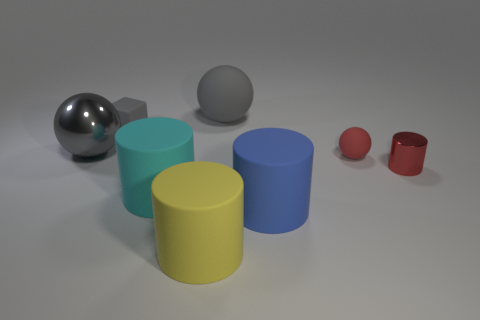Subtract all big spheres. How many spheres are left? 1 Subtract all gray balls. How many balls are left? 1 Add 1 big matte cylinders. How many objects exist? 9 Subtract 3 balls. How many balls are left? 0 Subtract all green cylinders. Subtract all green balls. How many cylinders are left? 4 Subtract all tiny red balls. Subtract all matte cylinders. How many objects are left? 4 Add 6 big matte things. How many big matte things are left? 10 Add 7 cyan objects. How many cyan objects exist? 8 Subtract 0 brown blocks. How many objects are left? 8 Subtract all balls. How many objects are left? 5 